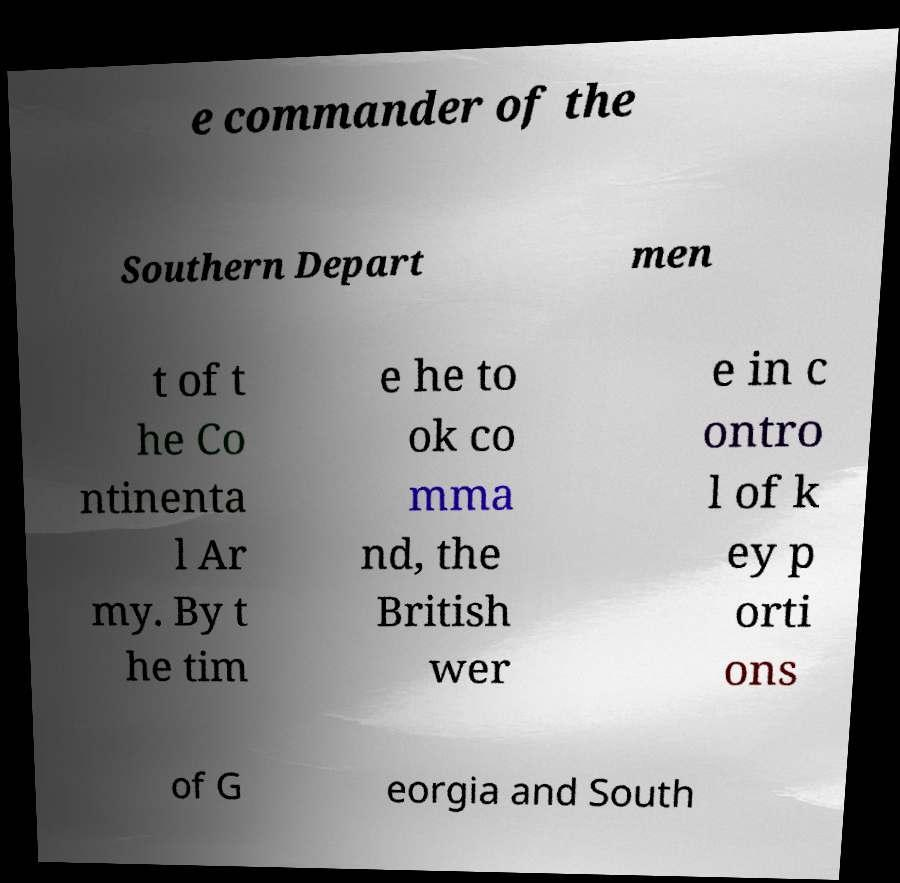For documentation purposes, I need the text within this image transcribed. Could you provide that? e commander of the Southern Depart men t of t he Co ntinenta l Ar my. By t he tim e he to ok co mma nd, the British wer e in c ontro l of k ey p orti ons of G eorgia and South 